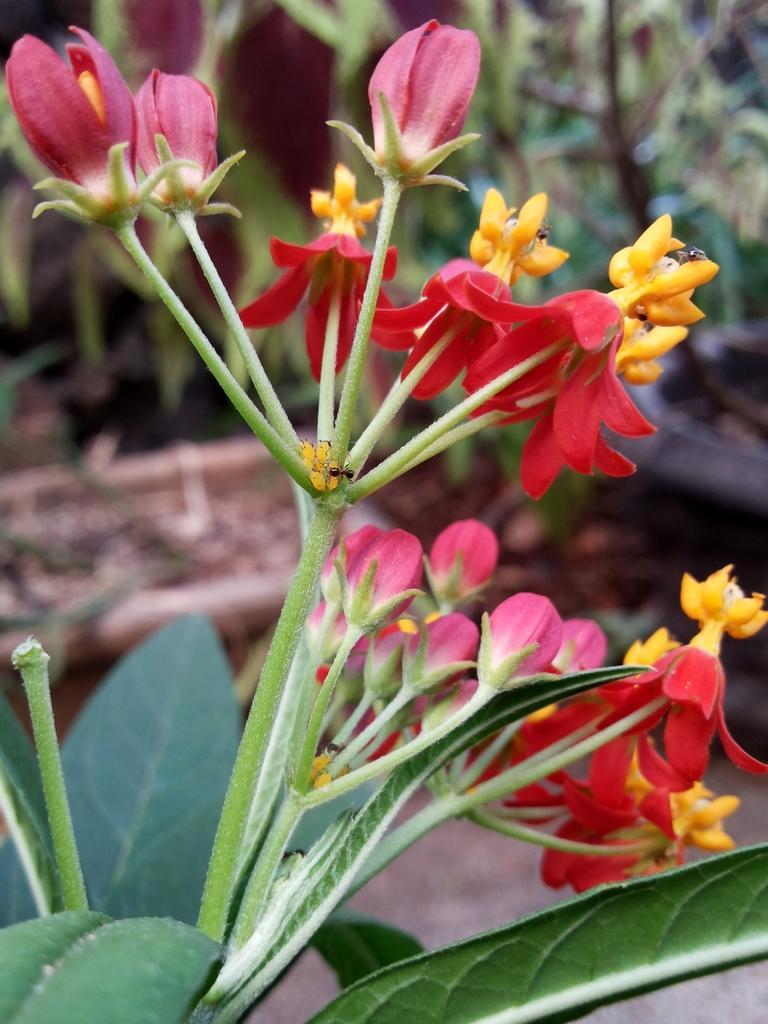Please provide a concise description of this image. In this image I can see the flowers to the plant. These flowers are in red, yellow and pink color. In the back I can see many plants. 